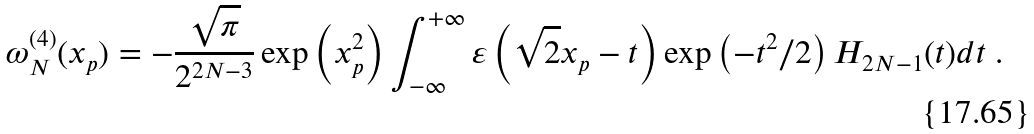<formula> <loc_0><loc_0><loc_500><loc_500>\omega _ { N } ^ { ( 4 ) } ( x _ { p } ) = - \frac { \sqrt { \pi } } { 2 ^ { 2 N - 3 } } \exp \left ( x _ { p } ^ { 2 } \right ) \int _ { - \infty } ^ { + \infty } \varepsilon \left ( \sqrt { 2 } x _ { p } - t \right ) \exp \left ( - t ^ { 2 } / 2 \right ) H _ { 2 N - 1 } ( t ) d t \ .</formula> 